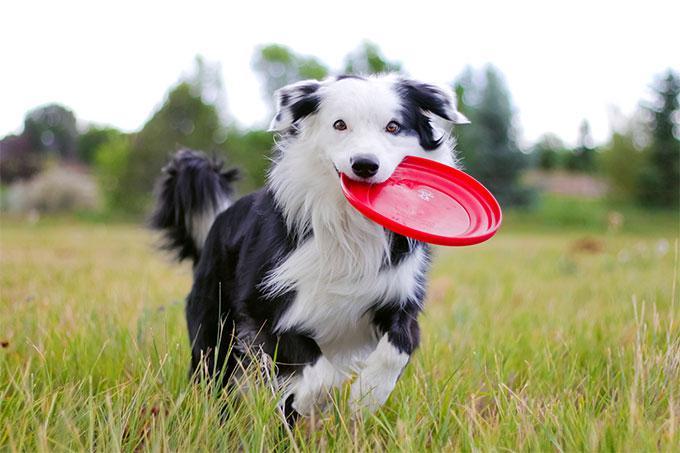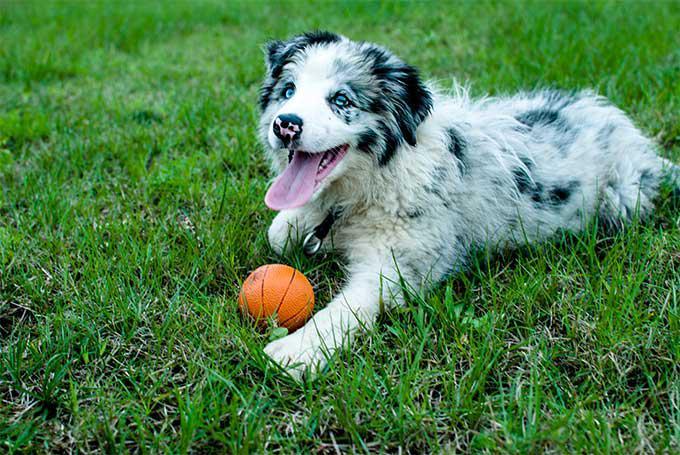The first image is the image on the left, the second image is the image on the right. Given the left and right images, does the statement "In one image, a dog is shown with sheep." hold true? Answer yes or no. No. The first image is the image on the left, the second image is the image on the right. Assess this claim about the two images: "There are two dogs". Correct or not? Answer yes or no. Yes. 